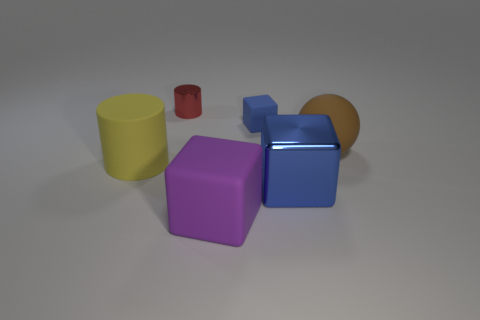What number of matte objects are big purple blocks or red cylinders?
Provide a succinct answer. 1. What material is the red thing?
Offer a terse response. Metal. There is a small blue block; what number of purple things are behind it?
Ensure brevity in your answer.  0. Are the small thing that is right of the shiny cylinder and the large sphere made of the same material?
Your response must be concise. Yes. How many large rubber things are the same shape as the tiny blue thing?
Your answer should be compact. 1. How many big objects are either brown balls or blue matte objects?
Your response must be concise. 1. There is a tiny thing left of the purple rubber object; is its color the same as the large matte cylinder?
Make the answer very short. No. Do the cube that is behind the brown ball and the big rubber thing right of the blue metal thing have the same color?
Ensure brevity in your answer.  No. Is there a large purple cube that has the same material as the brown sphere?
Provide a short and direct response. Yes. What number of brown things are small matte things or balls?
Offer a terse response. 1. 